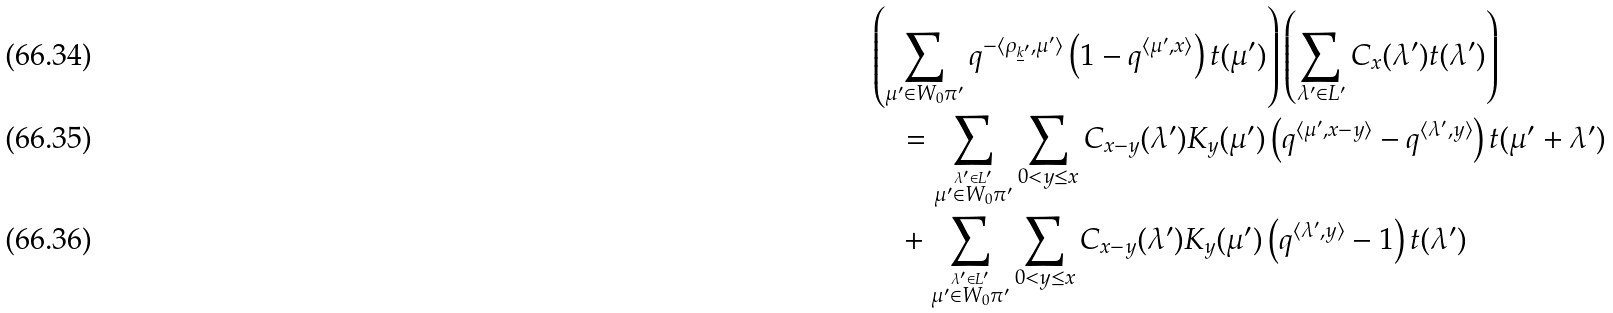Convert formula to latex. <formula><loc_0><loc_0><loc_500><loc_500>& \left ( \sum _ { \mu ^ { \prime } \in W _ { 0 } \pi ^ { \prime } } q ^ { - \langle \rho _ { \underline { k } ^ { \prime } } , \mu ^ { \prime } \rangle } \left ( 1 - q ^ { \langle \mu ^ { \prime } , x \rangle } \right ) t ( \mu ^ { \prime } ) \right ) \left ( \sum _ { \lambda ^ { \prime } \in L ^ { \prime } } C _ { x } ( \lambda ^ { \prime } ) t ( \lambda ^ { \prime } ) \right ) \\ & \quad = \sum _ { \stackrel { \lambda ^ { \prime } \in L ^ { \prime } } { \mu ^ { \prime } \in W _ { 0 } \pi ^ { \prime } } } \sum _ { 0 < y \leq x } C _ { x - y } ( \lambda ^ { \prime } ) K _ { y } ( \mu ^ { \prime } ) \left ( q ^ { \langle \mu ^ { \prime } , x - y \rangle } - q ^ { \langle \lambda ^ { \prime } , y \rangle } \right ) t ( \mu ^ { \prime } + \lambda ^ { \prime } ) \\ & \quad + \sum _ { \stackrel { \lambda ^ { \prime } \in L ^ { \prime } } { \mu ^ { \prime } \in W _ { 0 } \pi ^ { \prime } } } \sum _ { 0 < y \leq x } C _ { x - y } ( \lambda ^ { \prime } ) K _ { y } ( \mu ^ { \prime } ) \left ( q ^ { \langle \lambda ^ { \prime } , y \rangle } - 1 \right ) t ( \lambda ^ { \prime } )</formula> 